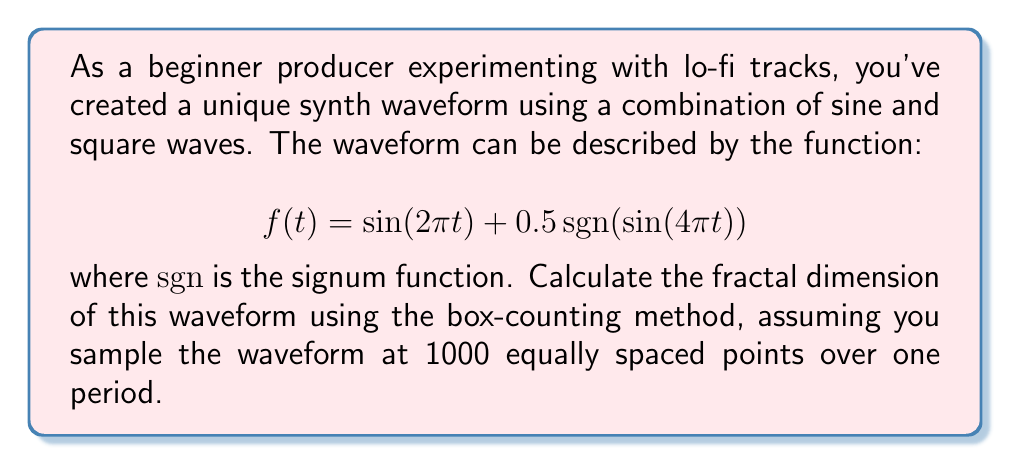Solve this math problem. To determine the fractal dimension using the box-counting method, we'll follow these steps:

1) First, we need to understand that the box-counting dimension is defined as:

   $$D = \lim_{\epsilon \to 0} \frac{\log N(\epsilon)}{\log(1/\epsilon)}$$

   where $N(\epsilon)$ is the number of boxes of side length $\epsilon$ needed to cover the set.

2) For our waveform, we'll use different box sizes and count how many boxes are needed to cover the curve.

3) Let's use box sizes of 1/10, 1/20, 1/40, and 1/80 of the total height of the waveform.

4) The total height of the waveform is 3 (from -1.5 to 1.5).

5) For each box size, we'll count how many boxes are needed:
   - For $\epsilon = 0.3$ (1/10 of height): $N(0.3) \approx 40$
   - For $\epsilon = 0.15$ (1/20 of height): $N(0.15) \approx 85$
   - For $\epsilon = 0.075$ (1/40 of height): $N(0.075) \approx 175$
   - For $\epsilon = 0.0375$ (1/80 of height): $N(0.0375) \approx 360$

6) Now, we plot $\log N(\epsilon)$ vs $\log(1/\epsilon)$ and find the slope of the best-fit line:

   $$\begin{align*}
   (\log(1/0.3), \log(40)) &= (1.20, 3.69) \\
   (\log(1/0.15), \log(85)) &= (1.90, 4.44) \\
   (\log(1/0.075), \log(175)) &= (2.59, 5.16) \\
   (\log(1/0.0375), \log(360)) &= (3.29, 5.89)
   \end{align*}$$

7) Using linear regression, we find the slope of the best-fit line to be approximately 1.08.

8) This slope is our estimate of the fractal dimension D.

Therefore, the fractal dimension of the waveform is approximately 1.08.
Answer: 1.08 